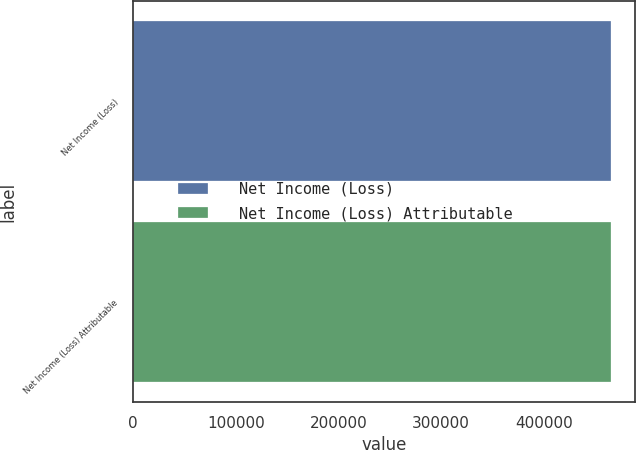<chart> <loc_0><loc_0><loc_500><loc_500><bar_chart><fcel>Net Income (Loss)<fcel>Net Income (Loss) Attributable<nl><fcel>465341<fcel>465341<nl></chart> 